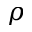<formula> <loc_0><loc_0><loc_500><loc_500>\rho</formula> 